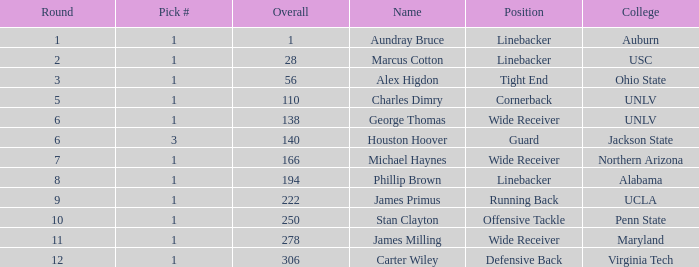In what Round with an Overall greater than 306 was the pick from the College of Virginia Tech? 0.0. 